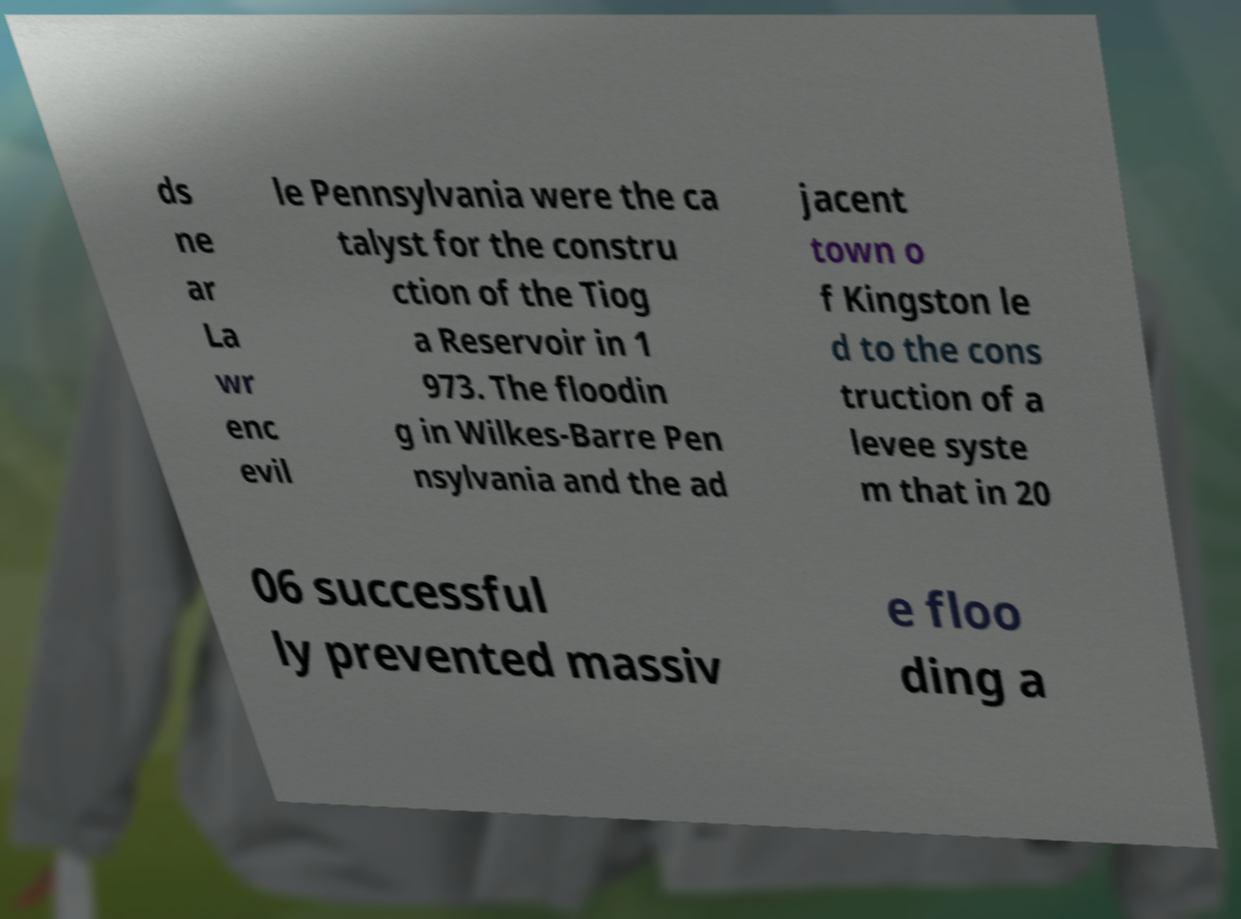There's text embedded in this image that I need extracted. Can you transcribe it verbatim? ds ne ar La wr enc evil le Pennsylvania were the ca talyst for the constru ction of the Tiog a Reservoir in 1 973. The floodin g in Wilkes-Barre Pen nsylvania and the ad jacent town o f Kingston le d to the cons truction of a levee syste m that in 20 06 successful ly prevented massiv e floo ding a 